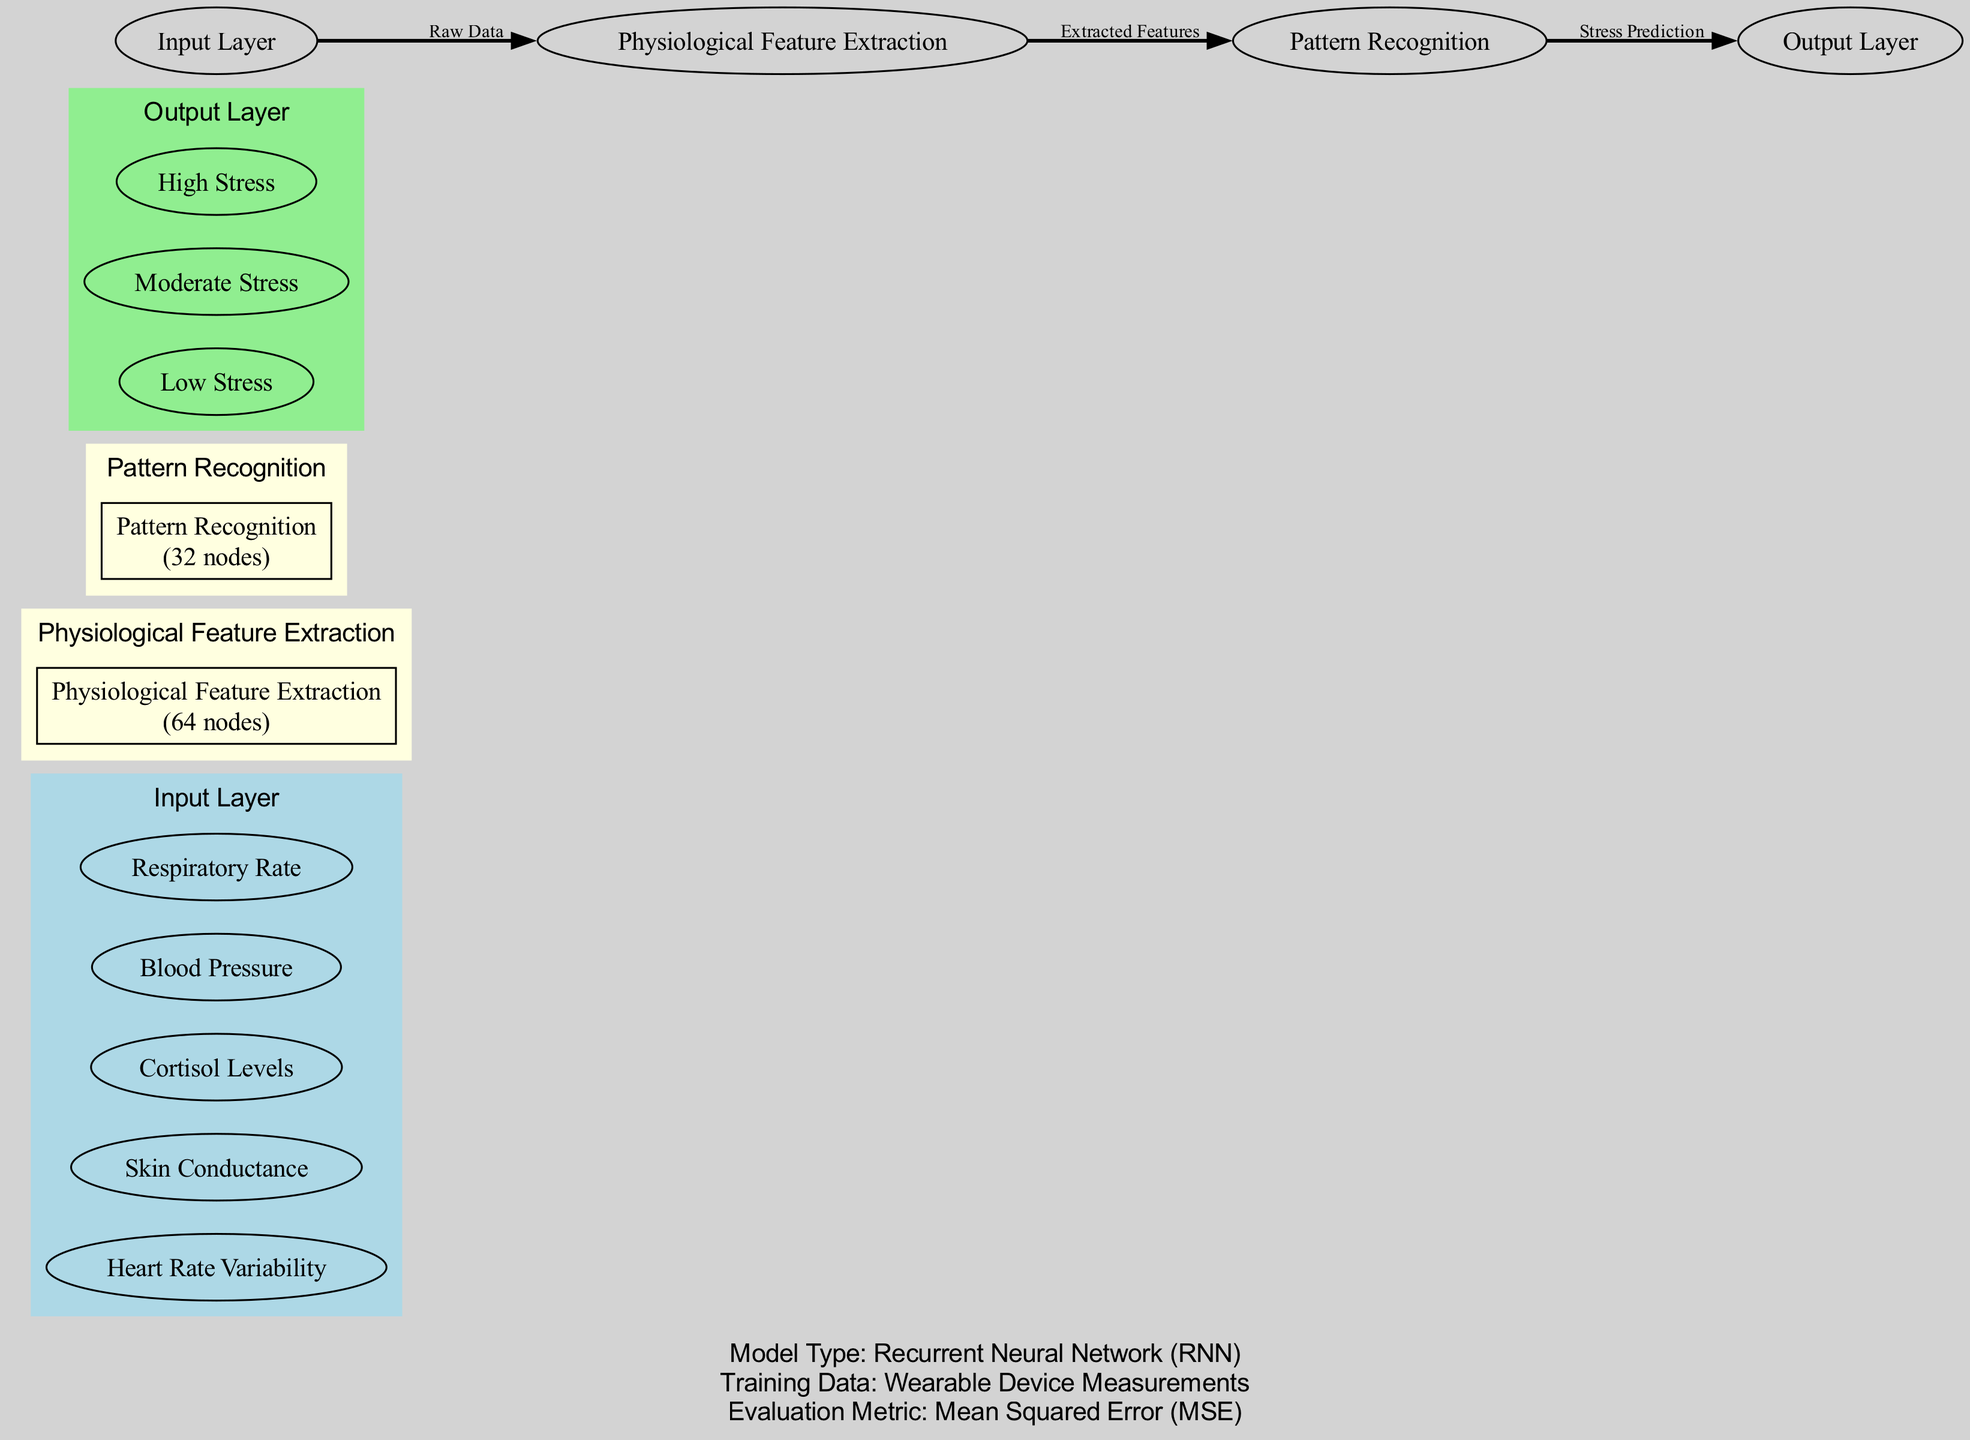What are the inputs to the neural network? The diagram lists five specific physiological data inputs, which are Heart Rate Variability, Skin Conductance, Cortisol Levels, Blood Pressure, and Respiratory Rate.
Answer: Heart Rate Variability, Skin Conductance, Cortisol Levels, Blood Pressure, Respiratory Rate How many nodes are in the Pattern Recognition layer? According to the diagram, the Pattern Recognition layer has 32 nodes indicated next to its name within the box shape.
Answer: 32 What is the evaluation metric used for this model? The diagram explicitly states that the evaluation metric for this model is Mean Squared Error. This is mentioned in the model information section at the bottom of the diagram.
Answer: Mean Squared Error Which layer connects Physiological Feature Extraction to Pattern Recognition? The arrow connecting these two layers is labeled as "Extracted Features." The flow shows that after features are extracted from the input data, they are fed into the Pattern Recognition layer.
Answer: Extracted Features How many hidden layers are present in this neural network architecture? The diagram shows two distinct hidden layers labeled Physiological Feature Extraction and Pattern Recognition, confirming that there are a total of two hidden layers in the architecture.
Answer: 2 What type of neural network architecture is represented in this diagram? The model type is stated clearly at the bottom of the diagram, affirming that the architecture is a Recurrent Neural Network. This provides a specific identifier for the kind of machine learning model being used.
Answer: Recurrent Neural Network What is the output of the neural network? The output layer consists of three stress levels: Low Stress, Moderate Stress, and High Stress. These outputs are represented as separate nodes within the output layer section of the diagram.
Answer: Low Stress, Moderate Stress, High Stress What is the connection labeled between Input Layer and Physiological Feature Extraction? The connection from the Input Layer to the Physiological Feature Extraction layer is labeled as "Raw Data," signifying that the raw physiological data is the input for feature extraction.
Answer: Raw Data What is the purpose of the hidden layer named Physiological Feature Extraction? This layer is responsible for extracting relevant features from the raw physiological data inputs, as inferred from its name and position in the data flow.
Answer: Extracting features from raw data 